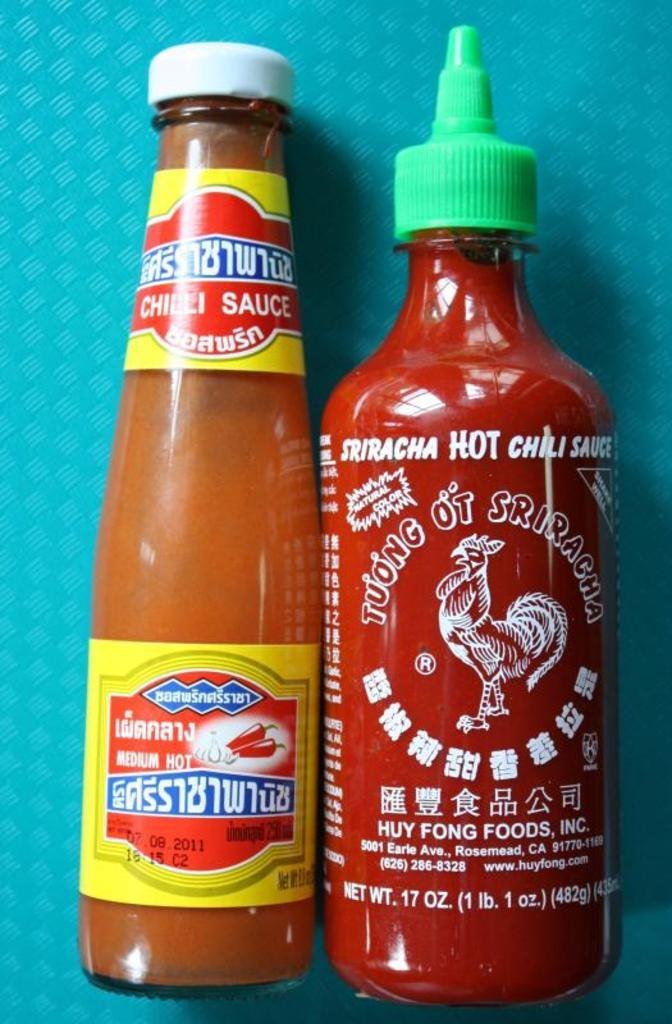<image>
Present a compact description of the photo's key features. two bottles of hot sauce next to one another with one labeled as 'siracha hot chili sauce' 